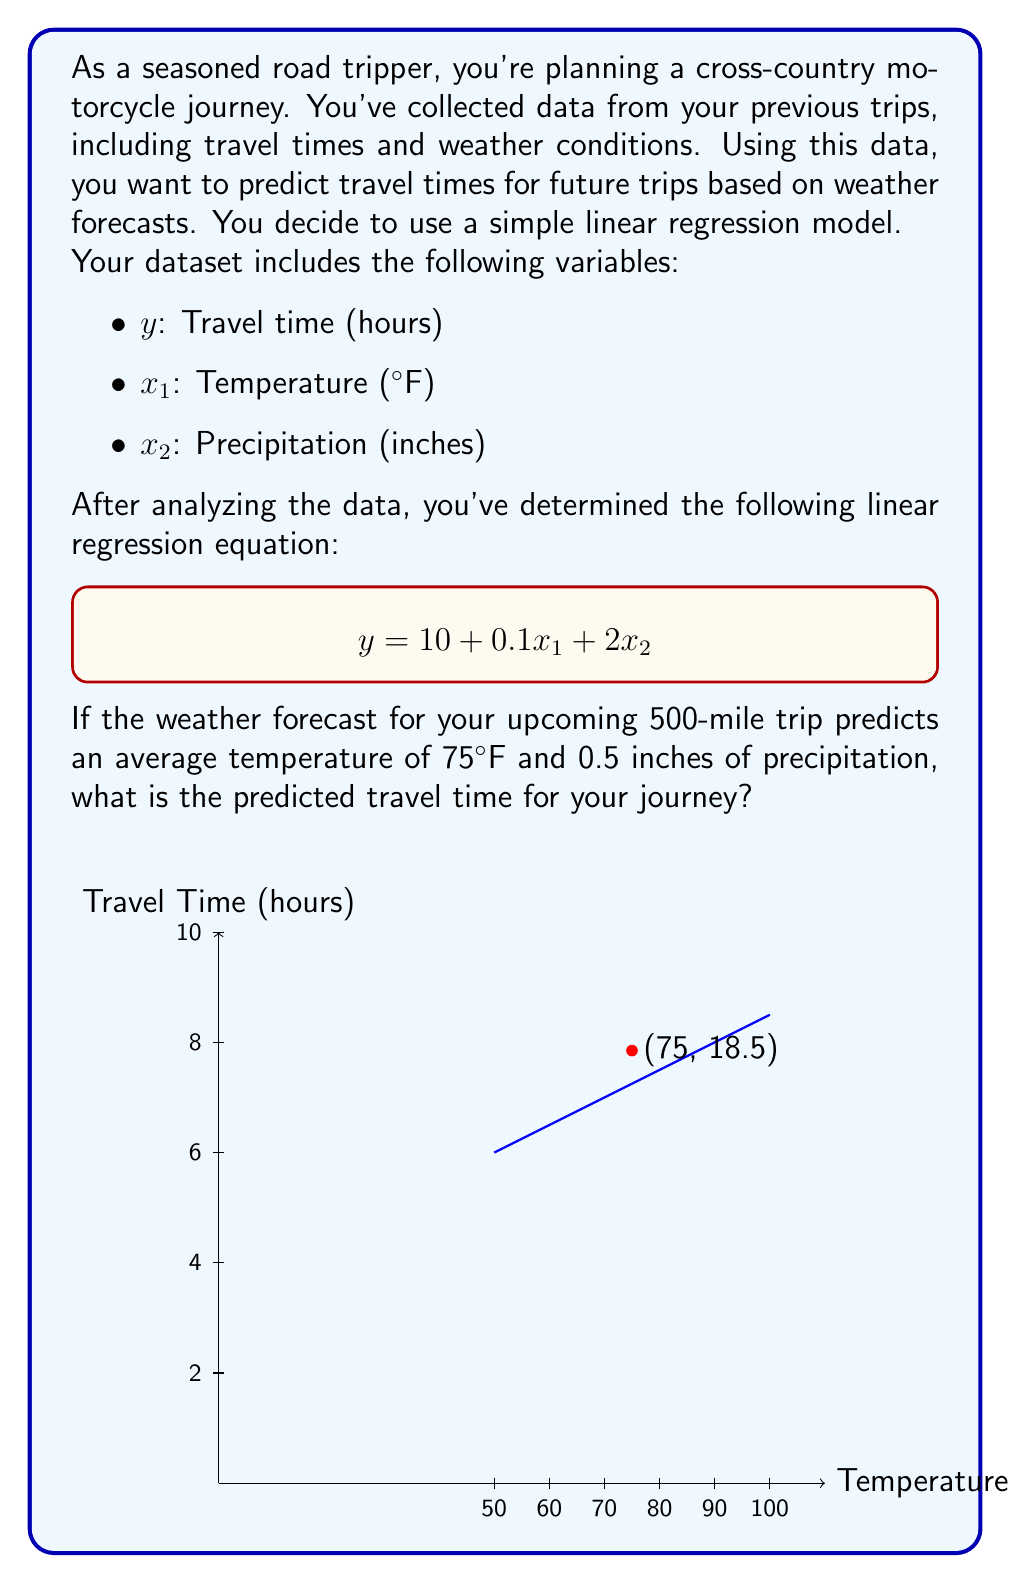Show me your answer to this math problem. To solve this problem, we'll use the given linear regression equation and plug in the values for temperature and precipitation:

1) The linear regression equation is:
   $$y = 10 + 0.1x_1 + 2x_2$$

2) We're given:
   - $x_1$ (Temperature) = 75°F
   - $x_2$ (Precipitation) = 0.5 inches

3) Let's substitute these values into the equation:
   $$y = 10 + 0.1(75) + 2(0.5)$$

4) Now, let's calculate step by step:
   $$y = 10 + 7.5 + 1$$
   $$y = 18.5$$

5) Therefore, the predicted travel time is 18.5 hours.

This linear regression model suggests that for every degree Fahrenheit increase in temperature, the travel time increases by 0.1 hours, and for every inch of precipitation, the travel time increases by 2 hours. The base travel time (when temperature and precipitation are both zero) is 10 hours.
Answer: 18.5 hours 